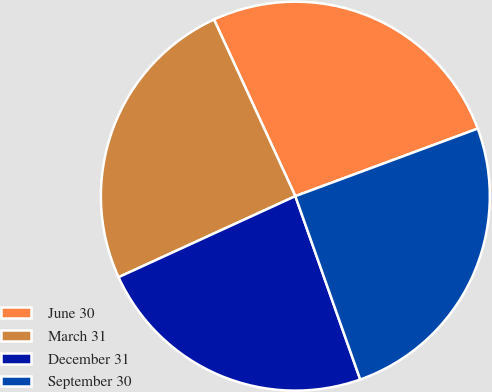Convert chart. <chart><loc_0><loc_0><loc_500><loc_500><pie_chart><fcel>June 30<fcel>March 31<fcel>December 31<fcel>September 30<nl><fcel>26.22%<fcel>24.97%<fcel>23.57%<fcel>25.23%<nl></chart> 